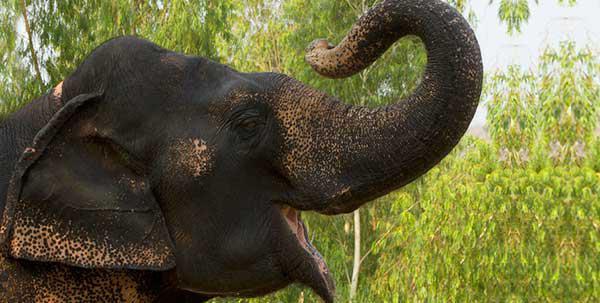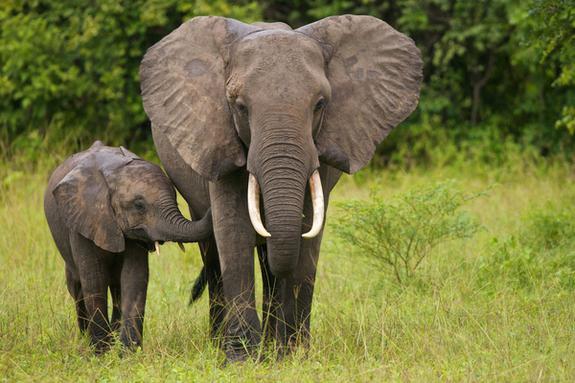The first image is the image on the left, the second image is the image on the right. Analyze the images presented: Is the assertion "The right image shows just one baby elephant next to one adult." valid? Answer yes or no. Yes. 